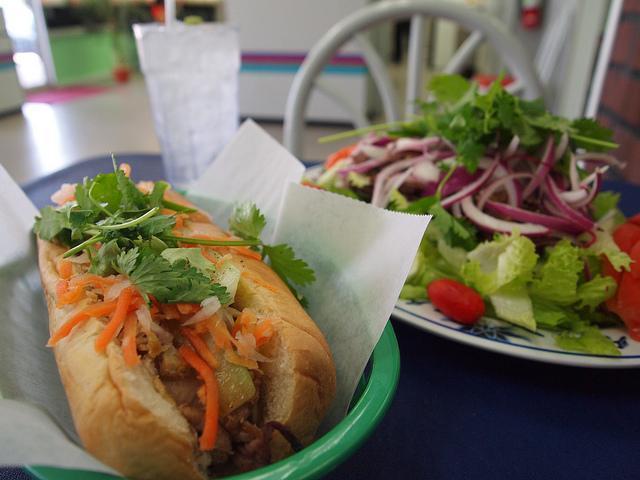How many sandwiches are there?
Give a very brief answer. 1. 